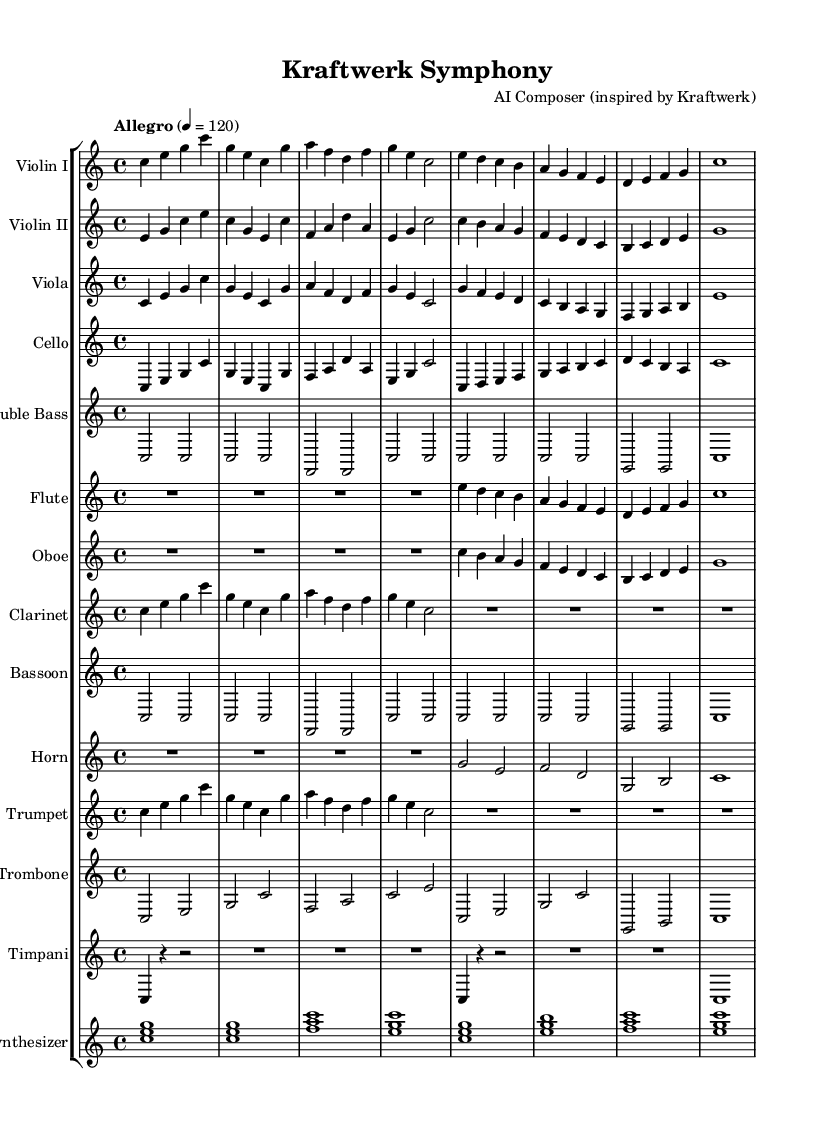What is the key signature of this music? The key signature is C major, which has no sharps or flats.
Answer: C major What is the time signature of this piece? The time signature is indicated as 4/4, which means there are four beats in each measure.
Answer: 4/4 What is the tempo marking for this score? The tempo marking is "Allegro" with a metronome marking of 120 beats per minute, indicating a fast tempo.
Answer: Allegro How many violin parts are written in this arrangement? There are two violin parts indicated, Violin I and Violin II, both listed in the score.
Answer: Two Which instruments are included in this orchestral arrangement? The score includes strings (Violin I, Violin II, Viola, Cello, Double Bass), woodwinds (Flute, Oboe, Clarinet, Bassoon), brass (Horn, Trumpet, Trombone), percussion (Timpani), and a Synthesizer.
Answer: Strings, woodwinds, brass, percussion, synthesizer What is the role of the synthesizer in the arrangement? The synthesizer part is played using chords that create a harmonic foundation and ambiance for the orchestral arrangement, indicated by its notation.
Answer: Harmonic foundation Which instrument has the lowest range in this piece? The Double Bass is the instrument with the lowest range based on its notation and typical instrumentation in orchestras.
Answer: Double Bass 